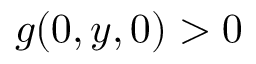Convert formula to latex. <formula><loc_0><loc_0><loc_500><loc_500>g ( 0 , y , 0 ) > 0</formula> 